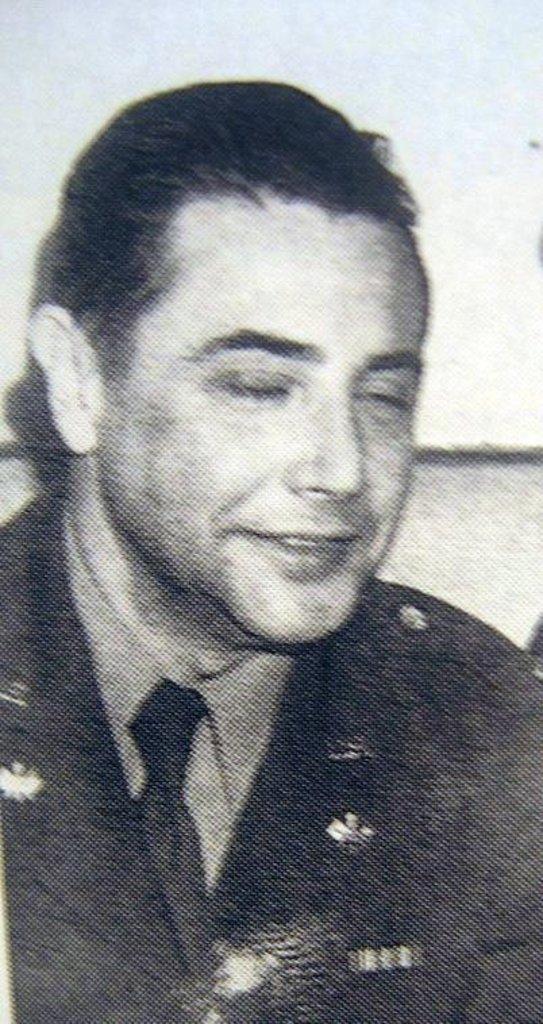How would you summarize this image in a sentence or two? This picture is black and white where we can see a person wearing blazer, tie and shirt is smiling by closing his eyes. 